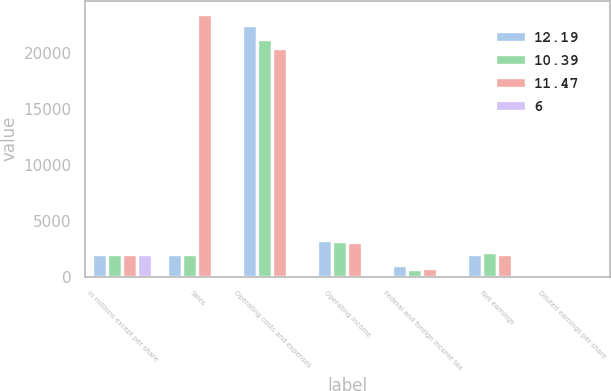Convert chart to OTSL. <chart><loc_0><loc_0><loc_500><loc_500><stacked_bar_chart><ecel><fcel>in millions except per share<fcel>Sales<fcel>Operating costs and expenses<fcel>Operating income<fcel>Federal and foreign income tax<fcel>Net earnings<fcel>Diluted earnings per share<nl><fcel>12.19<fcel>2017<fcel>2002.5<fcel>22504<fcel>3299<fcel>1034<fcel>2015<fcel>11.47<nl><fcel>10.39<fcel>2016<fcel>2002.5<fcel>21315<fcel>3193<fcel>723<fcel>2200<fcel>12.19<nl><fcel>11.47<fcel>2015<fcel>23526<fcel>20450<fcel>3076<fcel>800<fcel>1990<fcel>10.39<nl><fcel>6<fcel>2017<fcel>5<fcel>6<fcel>3<fcel>43<fcel>8<fcel>6<nl></chart> 